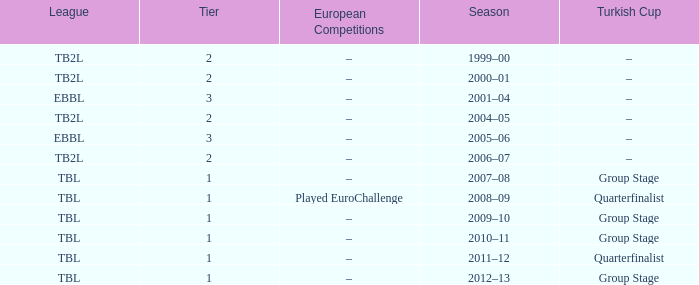Tier of 2, and a Season of 2000–01 is what European competitions? –. 